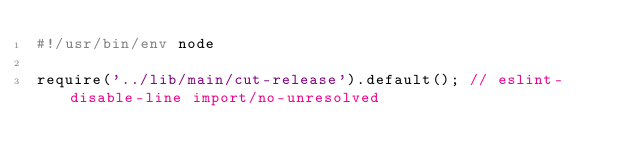Convert code to text. <code><loc_0><loc_0><loc_500><loc_500><_JavaScript_>#!/usr/bin/env node

require('../lib/main/cut-release').default(); // eslint-disable-line import/no-unresolved
</code> 